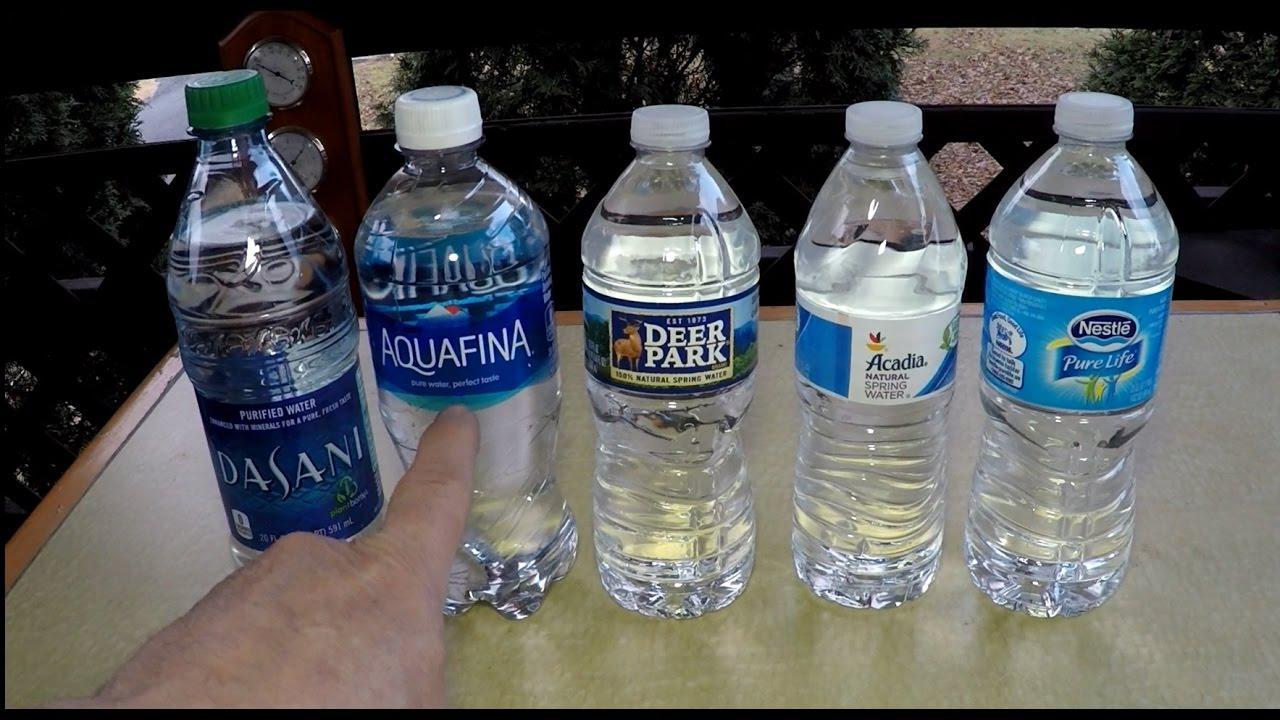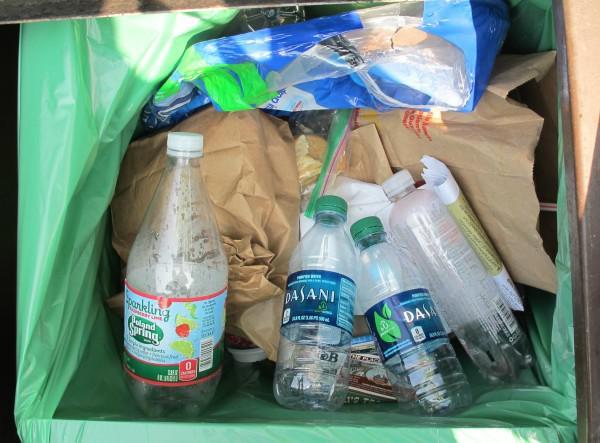The first image is the image on the left, the second image is the image on the right. Considering the images on both sides, is "The left and right image contains at least eight bottle of water in a plastic wrap." valid? Answer yes or no. No. The first image is the image on the left, the second image is the image on the right. Assess this claim about the two images: "There are water bottles with two or more different labels and shapes.". Correct or not? Answer yes or no. Yes. 